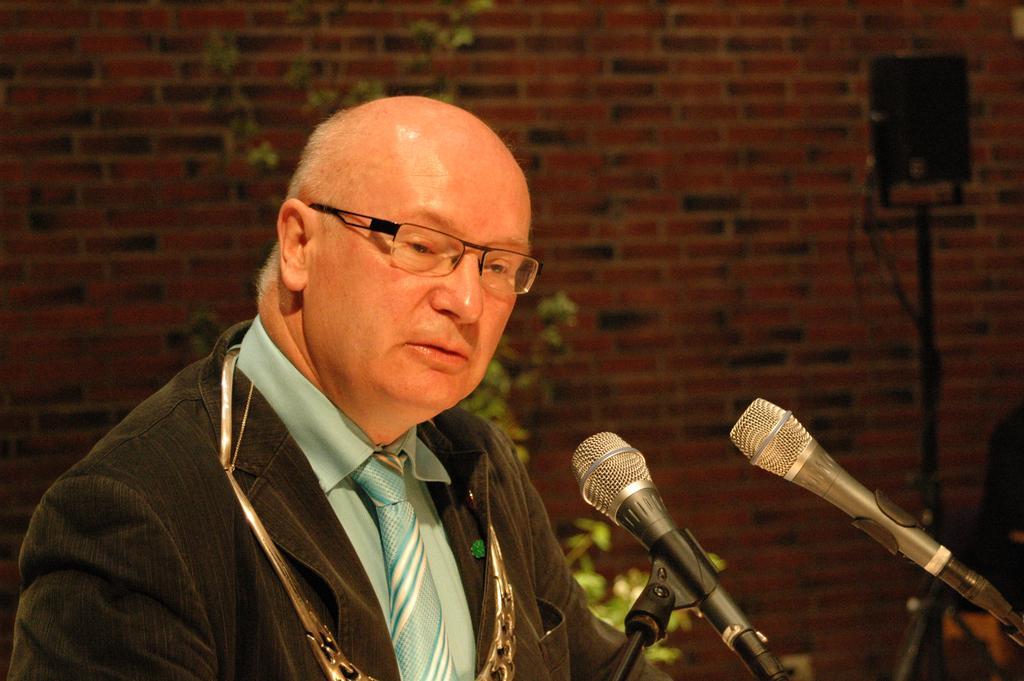Describe this image in one or two sentences. In this image there is a person standing, in front of him there are two mics, behind him there is a wall with red bricks. 